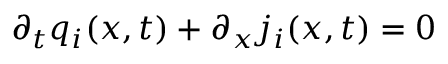Convert formula to latex. <formula><loc_0><loc_0><loc_500><loc_500>\partial _ { t } q _ { i } ( x , t ) + \partial _ { x } j _ { i } ( x , t ) = 0</formula> 